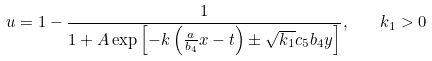Convert formula to latex. <formula><loc_0><loc_0><loc_500><loc_500>u = 1 - \frac { 1 } { 1 + A \exp \left [ - k \left ( \frac { a } { b _ { 4 } } x - t \right ) \pm \sqrt { k _ { 1 } } c _ { 5 } b _ { 4 } y \right ] } , \quad k _ { 1 } > 0</formula> 